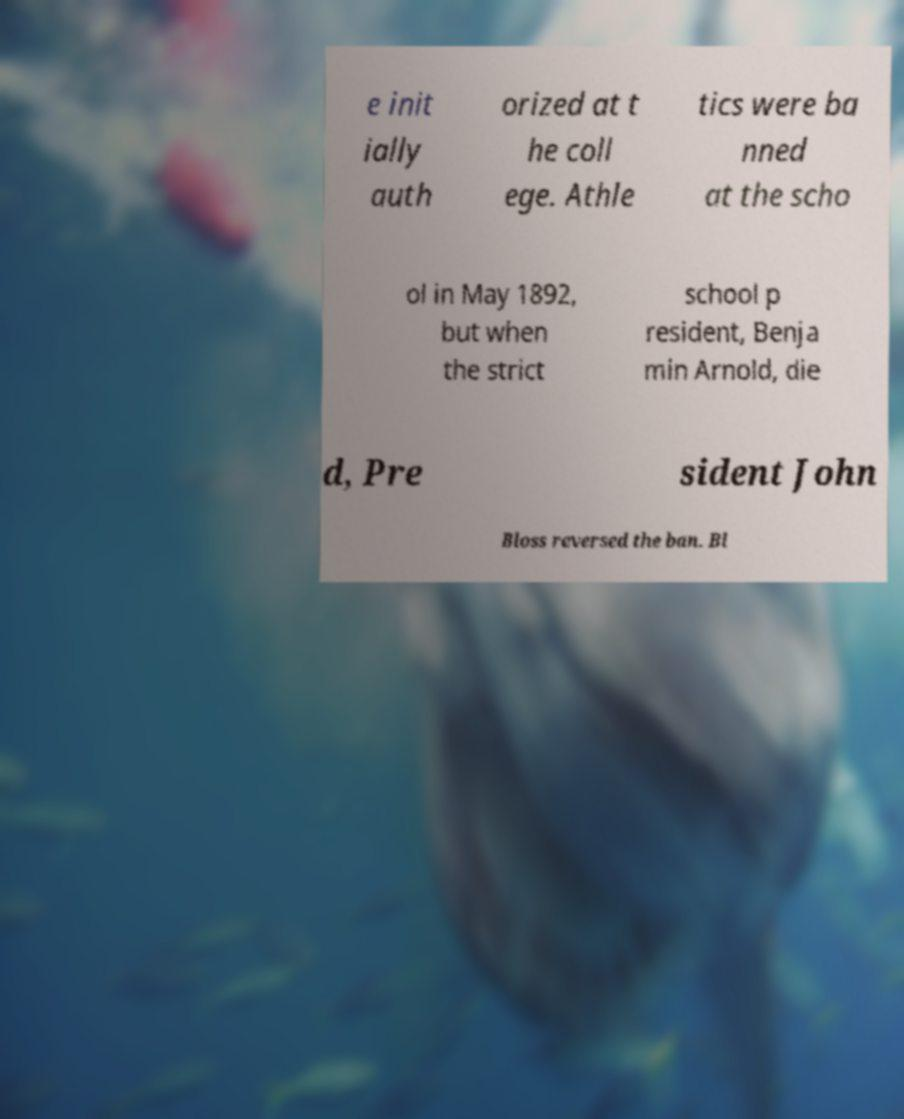Please identify and transcribe the text found in this image. e init ially auth orized at t he coll ege. Athle tics were ba nned at the scho ol in May 1892, but when the strict school p resident, Benja min Arnold, die d, Pre sident John Bloss reversed the ban. Bl 